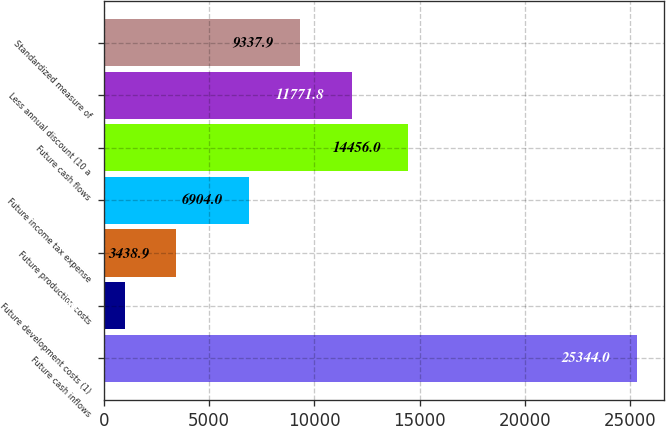Convert chart to OTSL. <chart><loc_0><loc_0><loc_500><loc_500><bar_chart><fcel>Future cash inflows<fcel>Future development costs (1)<fcel>Future production costs<fcel>Future income tax expense<fcel>Future cash flows<fcel>Less annual discount (10 a<fcel>Standardized measure of<nl><fcel>25344<fcel>1005<fcel>3438.9<fcel>6904<fcel>14456<fcel>11771.8<fcel>9337.9<nl></chart> 